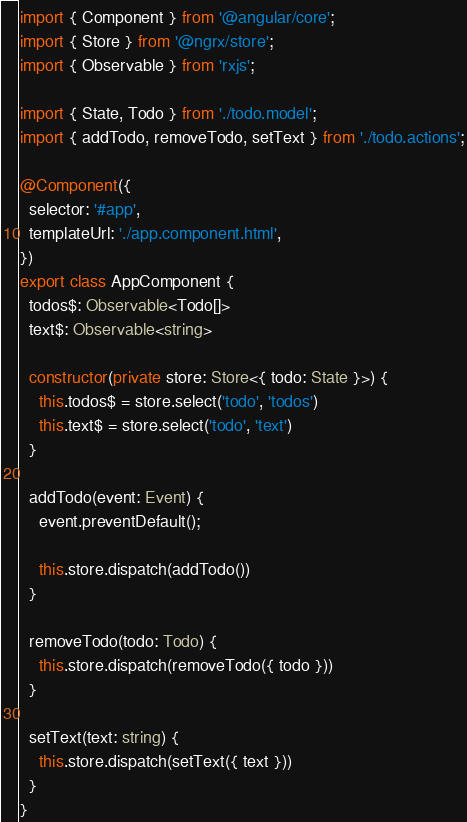<code> <loc_0><loc_0><loc_500><loc_500><_TypeScript_>import { Component } from '@angular/core';
import { Store } from '@ngrx/store';
import { Observable } from 'rxjs';

import { State, Todo } from './todo.model';
import { addTodo, removeTodo, setText } from './todo.actions';

@Component({
  selector: '#app',
  templateUrl: './app.component.html',
})
export class AppComponent {
  todos$: Observable<Todo[]>
  text$: Observable<string>

  constructor(private store: Store<{ todo: State }>) {
    this.todos$ = store.select('todo', 'todos')
    this.text$ = store.select('todo', 'text')
  }

  addTodo(event: Event) {
    event.preventDefault();

    this.store.dispatch(addTodo())
  }

  removeTodo(todo: Todo) {
    this.store.dispatch(removeTodo({ todo }))
  }

  setText(text: string) {
    this.store.dispatch(setText({ text }))
  }
}
</code> 